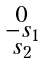<formula> <loc_0><loc_0><loc_500><loc_500>\begin{smallmatrix} 0 \\ - s _ { 1 } \\ s _ { 2 } \end{smallmatrix}</formula> 